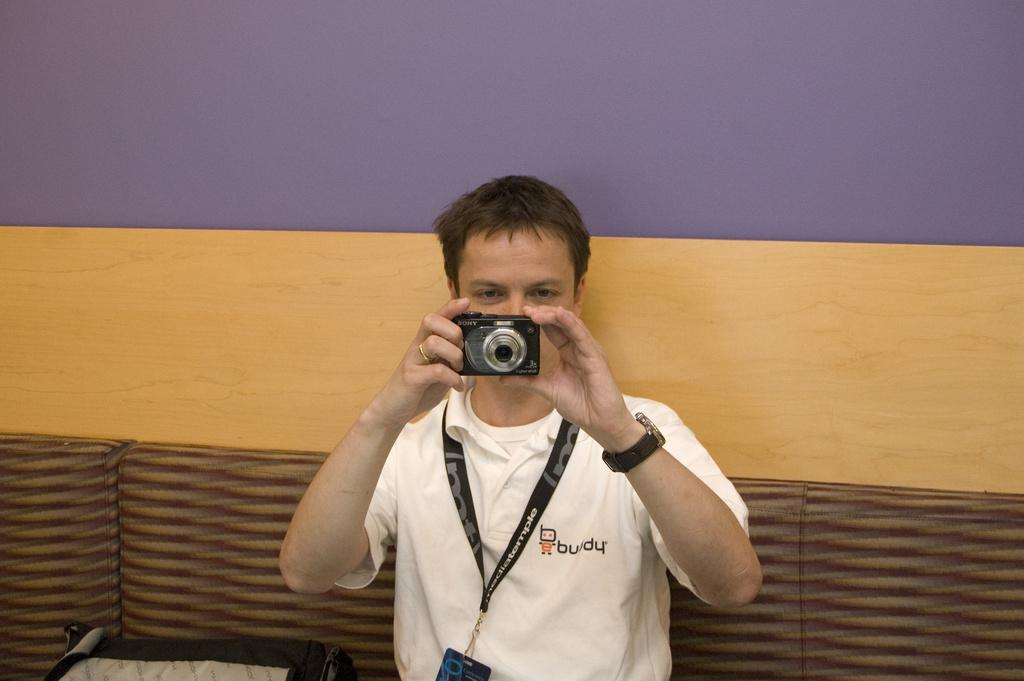Who is in the image? There is a man in the image. What is the man wearing? The man is wearing a white t-shirt. What is the man holding in the image? The man is holding a camera. What is the man doing with the camera? The man is capturing a photo. What can be seen in the background of the image? There is a wall with blue and brown colors in the background, and a sofa below the wall. What type of apple is growing on the wall in the image? There are no apples present in the image; the wall has blue and brown colors. 